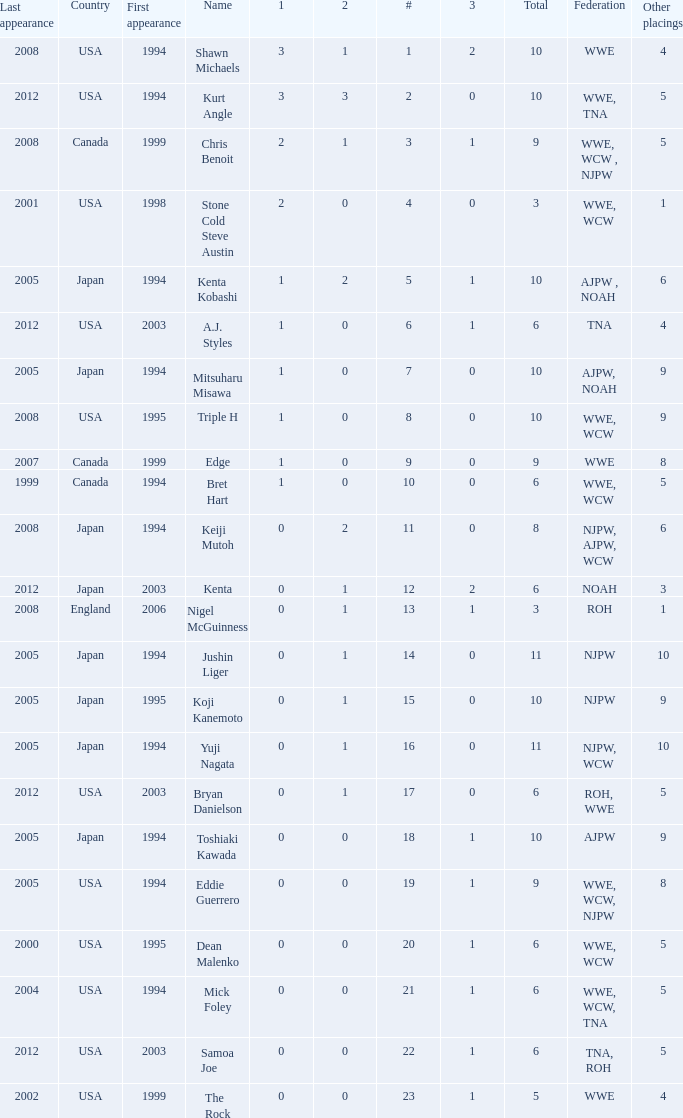How many times has a wrestler whose federation was roh, wwe competed in this event? 1.0. Can you give me this table as a dict? {'header': ['Last appearance', 'Country', 'First appearance', 'Name', '1', '2', '#', '3', 'Total', 'Federation', 'Other placings'], 'rows': [['2008', 'USA', '1994', 'Shawn Michaels', '3', '1', '1', '2', '10', 'WWE', '4'], ['2012', 'USA', '1994', 'Kurt Angle', '3', '3', '2', '0', '10', 'WWE, TNA', '5'], ['2008', 'Canada', '1999', 'Chris Benoit', '2', '1', '3', '1', '9', 'WWE, WCW , NJPW', '5'], ['2001', 'USA', '1998', 'Stone Cold Steve Austin', '2', '0', '4', '0', '3', 'WWE, WCW', '1'], ['2005', 'Japan', '1994', 'Kenta Kobashi', '1', '2', '5', '1', '10', 'AJPW , NOAH', '6'], ['2012', 'USA', '2003', 'A.J. Styles', '1', '0', '6', '1', '6', 'TNA', '4'], ['2005', 'Japan', '1994', 'Mitsuharu Misawa', '1', '0', '7', '0', '10', 'AJPW, NOAH', '9'], ['2008', 'USA', '1995', 'Triple H', '1', '0', '8', '0', '10', 'WWE, WCW', '9'], ['2007', 'Canada', '1999', 'Edge', '1', '0', '9', '0', '9', 'WWE', '8'], ['1999', 'Canada', '1994', 'Bret Hart', '1', '0', '10', '0', '6', 'WWE, WCW', '5'], ['2008', 'Japan', '1994', 'Keiji Mutoh', '0', '2', '11', '0', '8', 'NJPW, AJPW, WCW', '6'], ['2012', 'Japan', '2003', 'Kenta', '0', '1', '12', '2', '6', 'NOAH', '3'], ['2008', 'England', '2006', 'Nigel McGuinness', '0', '1', '13', '1', '3', 'ROH', '1'], ['2005', 'Japan', '1994', 'Jushin Liger', '0', '1', '14', '0', '11', 'NJPW', '10'], ['2005', 'Japan', '1995', 'Koji Kanemoto', '0', '1', '15', '0', '10', 'NJPW', '9'], ['2005', 'Japan', '1994', 'Yuji Nagata', '0', '1', '16', '0', '11', 'NJPW, WCW', '10'], ['2012', 'USA', '2003', 'Bryan Danielson', '0', '1', '17', '0', '6', 'ROH, WWE', '5'], ['2005', 'Japan', '1994', 'Toshiaki Kawada', '0', '0', '18', '1', '10', 'AJPW', '9'], ['2005', 'USA', '1994', 'Eddie Guerrero', '0', '0', '19', '1', '9', 'WWE, WCW, NJPW', '8'], ['2000', 'USA', '1995', 'Dean Malenko', '0', '0', '20', '1', '6', 'WWE, WCW', '5'], ['2004', 'USA', '1994', 'Mick Foley', '0', '0', '21', '1', '6', 'WWE, WCW, TNA', '5'], ['2012', 'USA', '2003', 'Samoa Joe', '0', '0', '22', '1', '6', 'TNA, ROH', '5'], ['2002', 'USA', '1999', 'The Rock', '0', '0', '23', '1', '5', 'WWE', '4']]} 